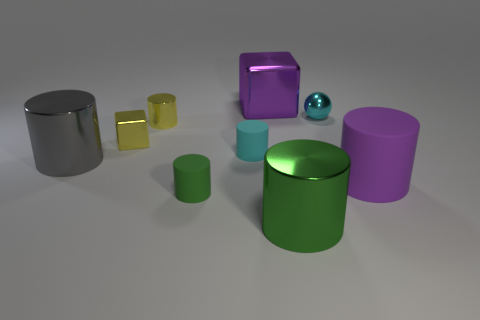Subtract all yellow cubes. How many cubes are left? 1 Subtract all big gray shiny cylinders. How many cylinders are left? 5 Subtract 0 brown balls. How many objects are left? 9 Subtract all spheres. How many objects are left? 8 Subtract 1 spheres. How many spheres are left? 0 Subtract all purple cylinders. Subtract all purple balls. How many cylinders are left? 5 Subtract all yellow spheres. How many blue cubes are left? 0 Subtract all tiny gray matte cubes. Subtract all tiny shiny cylinders. How many objects are left? 8 Add 1 small objects. How many small objects are left? 6 Add 6 big gray objects. How many big gray objects exist? 7 